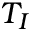Convert formula to latex. <formula><loc_0><loc_0><loc_500><loc_500>T _ { I }</formula> 